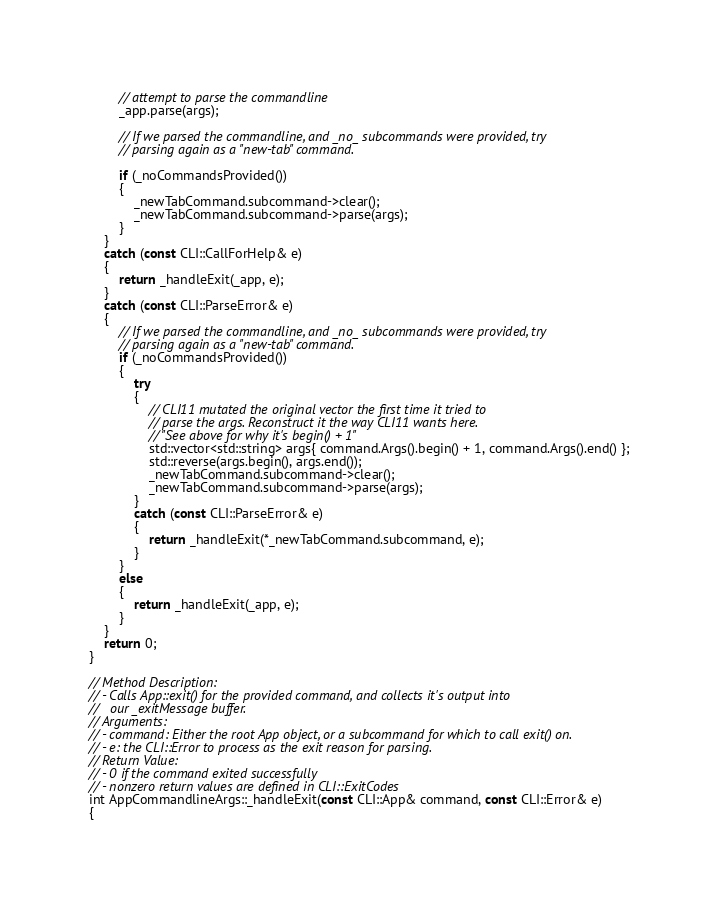Convert code to text. <code><loc_0><loc_0><loc_500><loc_500><_C++_>        // attempt to parse the commandline
        _app.parse(args);

        // If we parsed the commandline, and _no_ subcommands were provided, try
        // parsing again as a "new-tab" command.

        if (_noCommandsProvided())
        {
            _newTabCommand.subcommand->clear();
            _newTabCommand.subcommand->parse(args);
        }
    }
    catch (const CLI::CallForHelp& e)
    {
        return _handleExit(_app, e);
    }
    catch (const CLI::ParseError& e)
    {
        // If we parsed the commandline, and _no_ subcommands were provided, try
        // parsing again as a "new-tab" command.
        if (_noCommandsProvided())
        {
            try
            {
                // CLI11 mutated the original vector the first time it tried to
                // parse the args. Reconstruct it the way CLI11 wants here.
                // "See above for why it's begin() + 1"
                std::vector<std::string> args{ command.Args().begin() + 1, command.Args().end() };
                std::reverse(args.begin(), args.end());
                _newTabCommand.subcommand->clear();
                _newTabCommand.subcommand->parse(args);
            }
            catch (const CLI::ParseError& e)
            {
                return _handleExit(*_newTabCommand.subcommand, e);
            }
        }
        else
        {
            return _handleExit(_app, e);
        }
    }
    return 0;
}

// Method Description:
// - Calls App::exit() for the provided command, and collects it's output into
//   our _exitMessage buffer.
// Arguments:
// - command: Either the root App object, or a subcommand for which to call exit() on.
// - e: the CLI::Error to process as the exit reason for parsing.
// Return Value:
// - 0 if the command exited successfully
// - nonzero return values are defined in CLI::ExitCodes
int AppCommandlineArgs::_handleExit(const CLI::App& command, const CLI::Error& e)
{</code> 